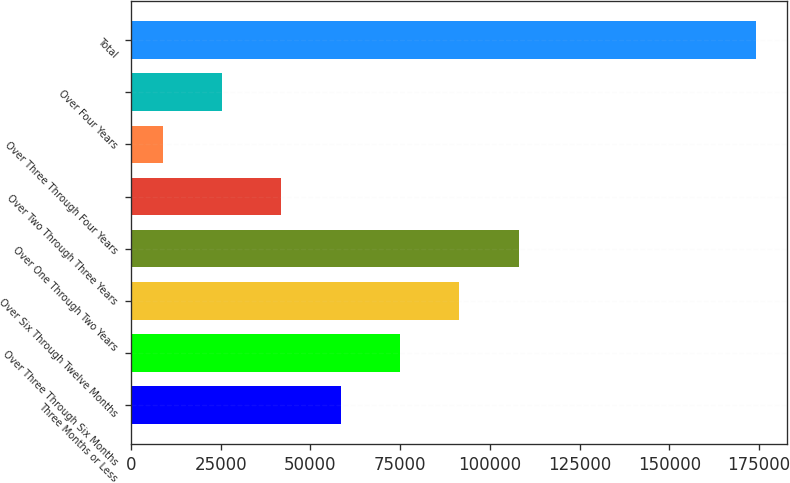<chart> <loc_0><loc_0><loc_500><loc_500><bar_chart><fcel>Three Months or Less<fcel>Over Three Through Six Months<fcel>Over Six Through Twelve Months<fcel>Over One Through Two Years<fcel>Over Two Through Three Years<fcel>Over Three Through Four Years<fcel>Over Four Years<fcel>Total<nl><fcel>58437<fcel>74965<fcel>91493<fcel>108021<fcel>41909<fcel>8853<fcel>25381<fcel>174133<nl></chart> 